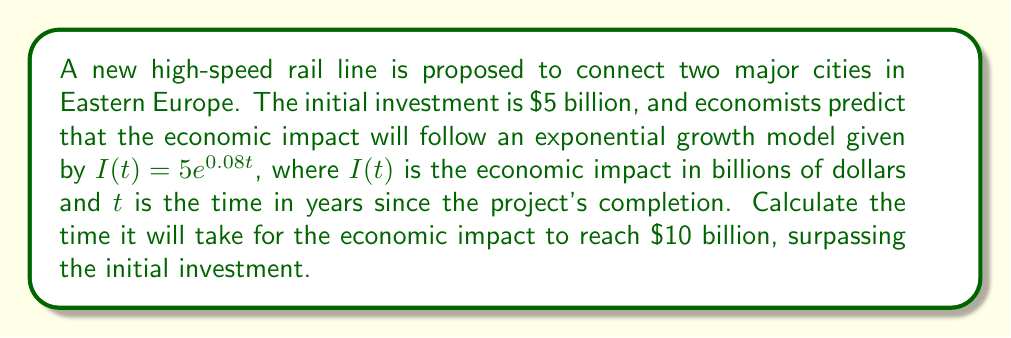Give your solution to this math problem. To solve this problem, we'll use the exponential growth model and solve for t:

1) The equation for the economic impact is:
   $I(t) = 5e^{0.08t}$

2) We want to find when $I(t) = 10$ billion:
   $10 = 5e^{0.08t}$

3) Divide both sides by 5:
   $2 = e^{0.08t}$

4) Take the natural logarithm of both sides:
   $\ln(2) = \ln(e^{0.08t})$

5) Simplify the right side using the properties of logarithms:
   $\ln(2) = 0.08t$

6) Solve for t:
   $t = \frac{\ln(2)}{0.08}$

7) Calculate the result:
   $t = \frac{0.693147...}{0.08} \approx 8.66$ years

Therefore, it will take approximately 8.66 years for the economic impact to reach $10 billion.
Answer: 8.66 years 